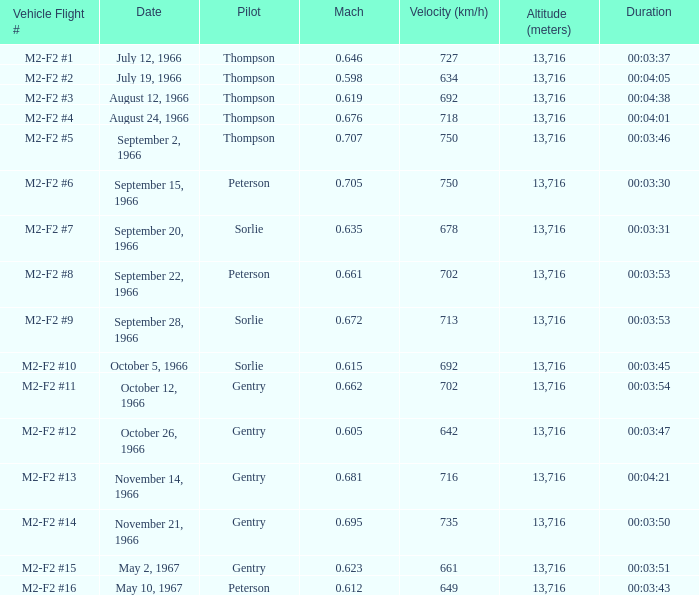Can you parse all the data within this table? {'header': ['Vehicle Flight #', 'Date', 'Pilot', 'Mach', 'Velocity (km/h)', 'Altitude (meters)', 'Duration'], 'rows': [['M2-F2 #1', 'July 12, 1966', 'Thompson', '0.646', '727', '13,716', '00:03:37'], ['M2-F2 #2', 'July 19, 1966', 'Thompson', '0.598', '634', '13,716', '00:04:05'], ['M2-F2 #3', 'August 12, 1966', 'Thompson', '0.619', '692', '13,716', '00:04:38'], ['M2-F2 #4', 'August 24, 1966', 'Thompson', '0.676', '718', '13,716', '00:04:01'], ['M2-F2 #5', 'September 2, 1966', 'Thompson', '0.707', '750', '13,716', '00:03:46'], ['M2-F2 #6', 'September 15, 1966', 'Peterson', '0.705', '750', '13,716', '00:03:30'], ['M2-F2 #7', 'September 20, 1966', 'Sorlie', '0.635', '678', '13,716', '00:03:31'], ['M2-F2 #8', 'September 22, 1966', 'Peterson', '0.661', '702', '13,716', '00:03:53'], ['M2-F2 #9', 'September 28, 1966', 'Sorlie', '0.672', '713', '13,716', '00:03:53'], ['M2-F2 #10', 'October 5, 1966', 'Sorlie', '0.615', '692', '13,716', '00:03:45'], ['M2-F2 #11', 'October 12, 1966', 'Gentry', '0.662', '702', '13,716', '00:03:54'], ['M2-F2 #12', 'October 26, 1966', 'Gentry', '0.605', '642', '13,716', '00:03:47'], ['M2-F2 #13', 'November 14, 1966', 'Gentry', '0.681', '716', '13,716', '00:04:21'], ['M2-F2 #14', 'November 21, 1966', 'Gentry', '0.695', '735', '13,716', '00:03:50'], ['M2-F2 #15', 'May 2, 1967', 'Gentry', '0.623', '661', '13,716', '00:03:51'], ['M2-F2 #16', 'May 10, 1967', 'Peterson', '0.612', '649', '13,716', '00:03:43']]} What is the mach number of vehicle flight # m2-f2 #8 when the altitude (meters) is above 13,716? None. 